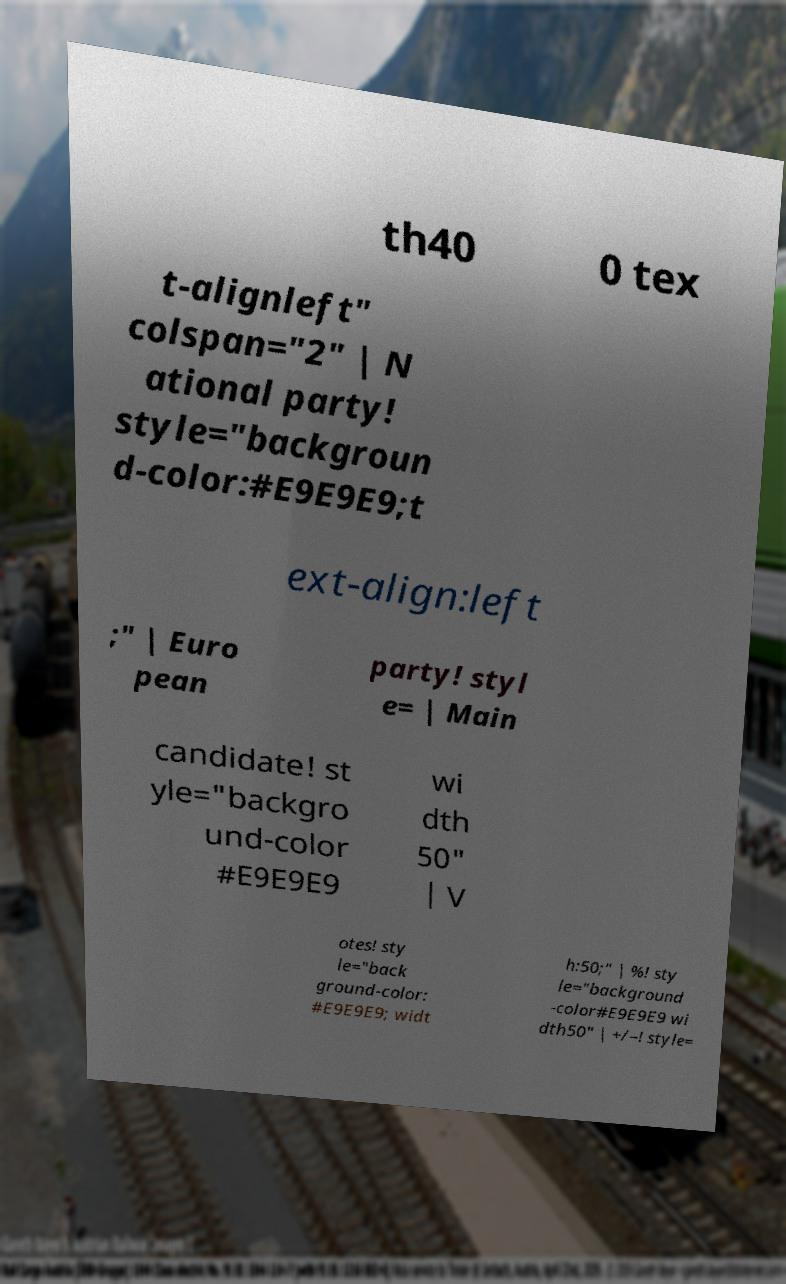I need the written content from this picture converted into text. Can you do that? th40 0 tex t-alignleft" colspan="2" | N ational party! style="backgroun d-color:#E9E9E9;t ext-align:left ;" | Euro pean party! styl e= | Main candidate! st yle="backgro und-color #E9E9E9 wi dth 50" | V otes! sty le="back ground-color: #E9E9E9; widt h:50;" | %! sty le="background -color#E9E9E9 wi dth50" | +/–! style= 